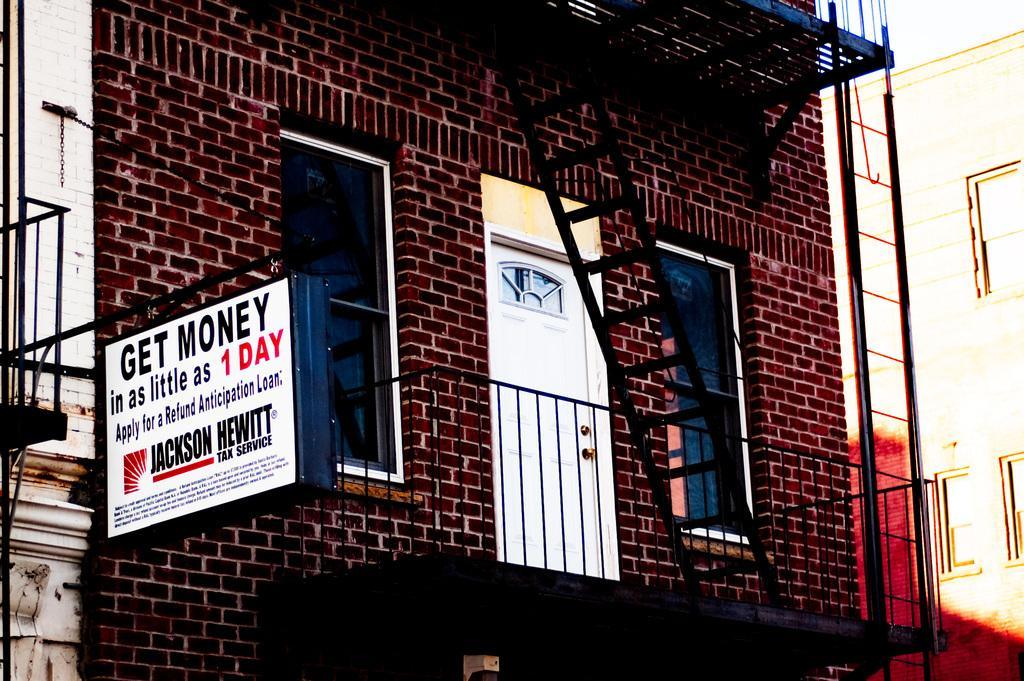What is the main structure in the image? There is a big building in the image. What type of windows does the building have? The building has glass windows. How can people enter the building? The building has a door. What is hanging outside the building? There is a board hanging outside the building. What is the weight of the ant crawling on the board outside the building? There is no ant present in the image, so it is not possible to determine its weight. 